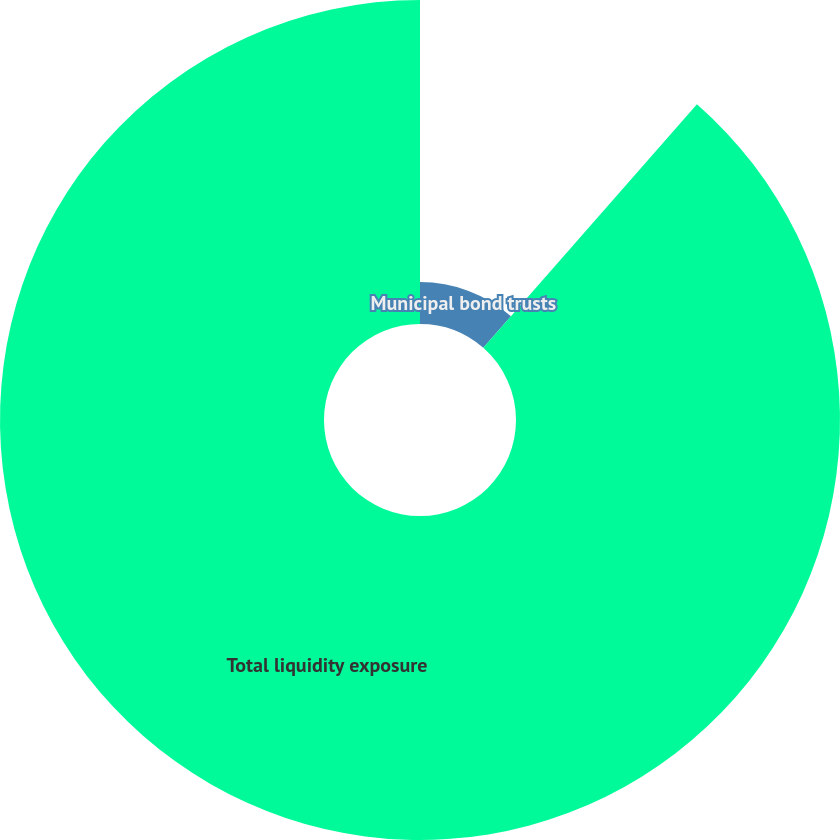Convert chart to OTSL. <chart><loc_0><loc_0><loc_500><loc_500><pie_chart><fcel>Municipal bond trusts<fcel>Total liquidity exposure<nl><fcel>11.46%<fcel>88.54%<nl></chart> 